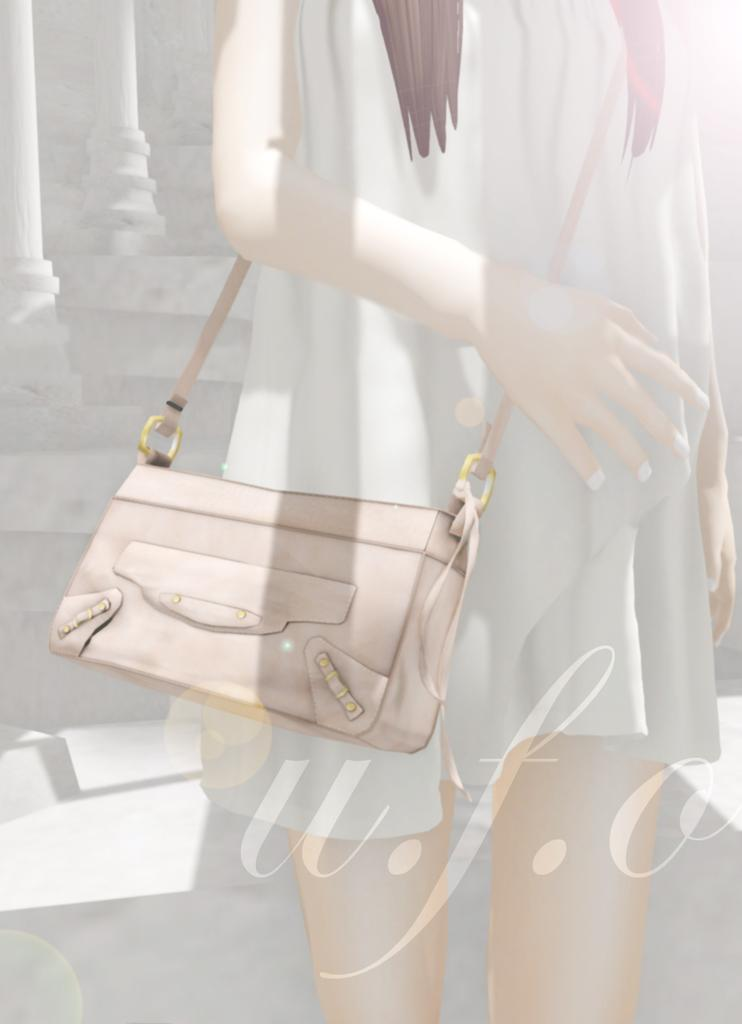What is the main subject of the image? There is a woman in the image. What is the woman holding or carrying? The woman is carrying a bag. What is the woman standing on? The woman is standing on the floor. What can be seen on the left side of the image? There are pillars on the left side of the image. What does the woman regret in the image? There is no indication in the image that the woman is experiencing regret, as the image only shows her standing and carrying a bag. 